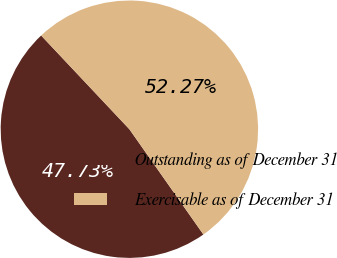Convert chart. <chart><loc_0><loc_0><loc_500><loc_500><pie_chart><fcel>Outstanding as of December 31<fcel>Exercisable as of December 31<nl><fcel>47.73%<fcel>52.27%<nl></chart> 